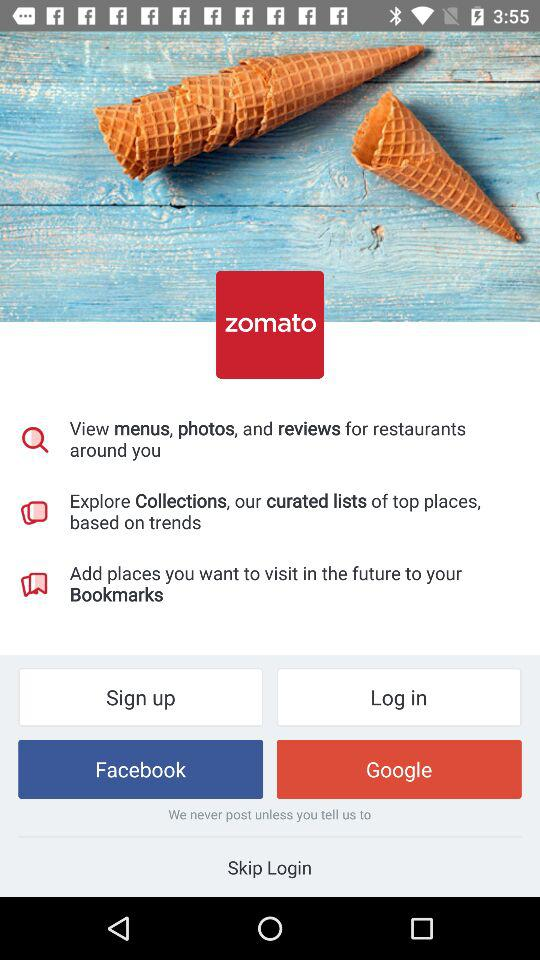Which are the different login options? The login option is "Google". 